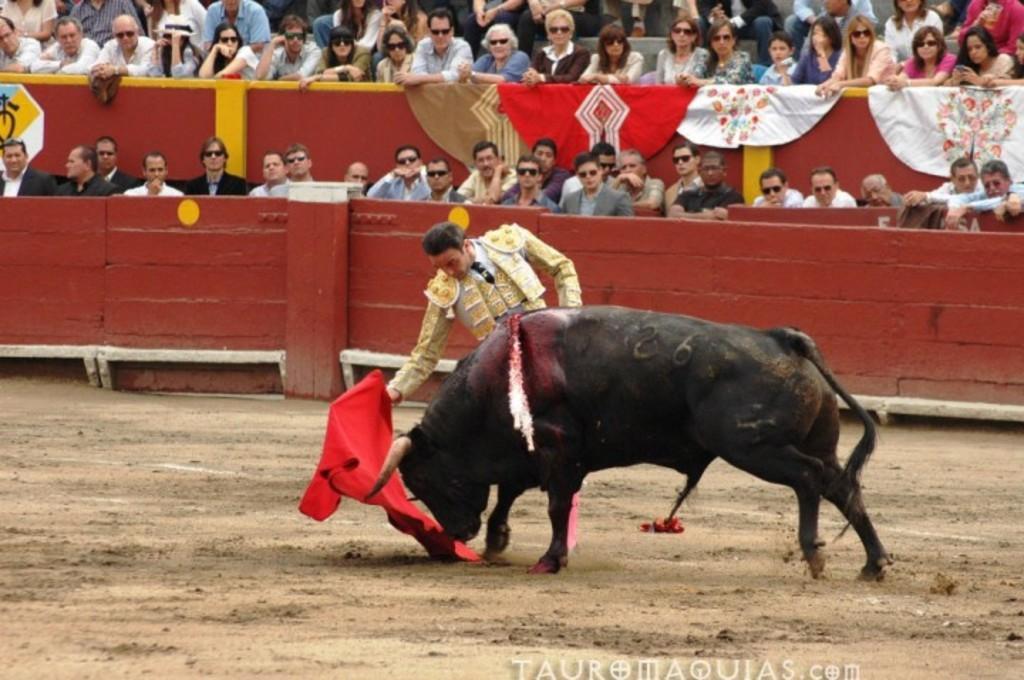Could you give a brief overview of what you see in this image? In this image I can see a black color animal. The person is holding red color flag. Back Side I can see few people are sitting. I can see a brown color fencing and few clothes are on it. 